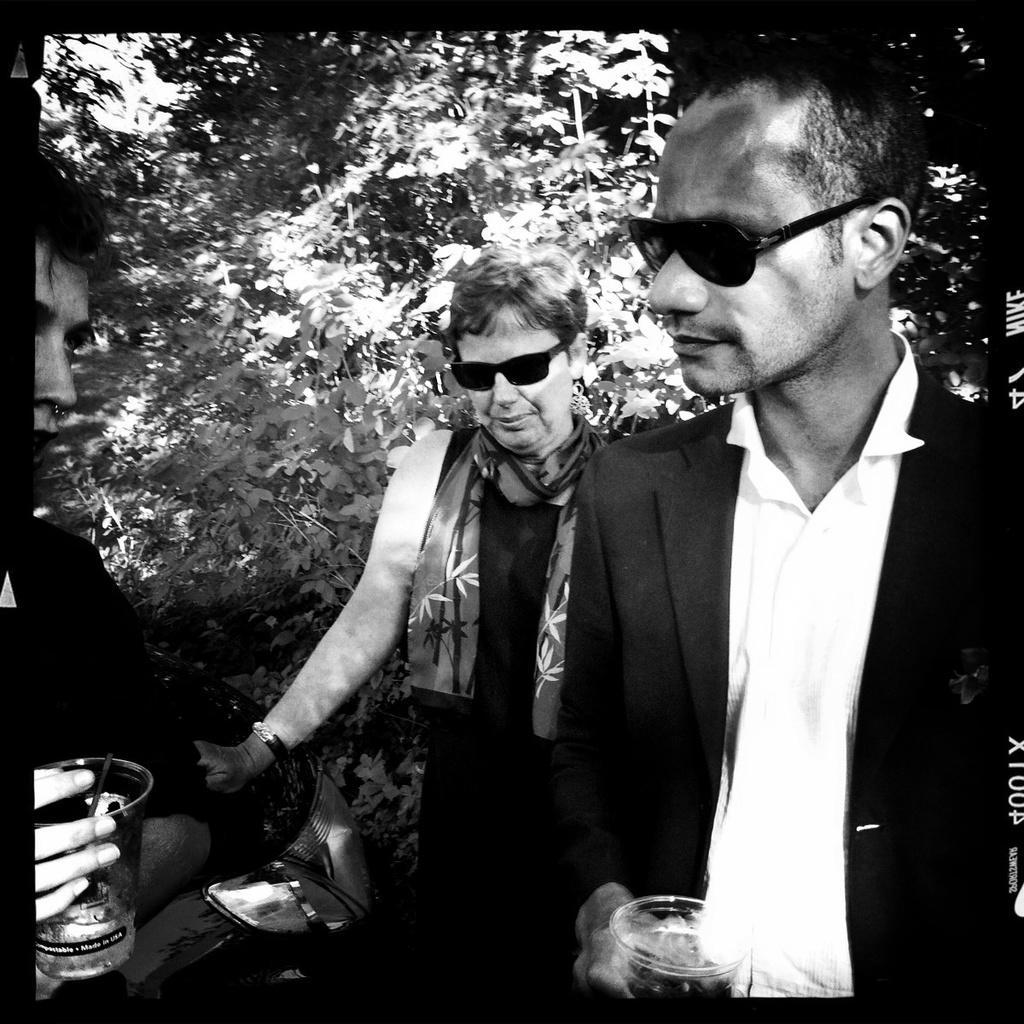Could you give a brief overview of what you see in this image? In this image, we can see three people and some people. Few are wearing glasses and holding glass with liquid. Background there are so many plants and trees we can see. 